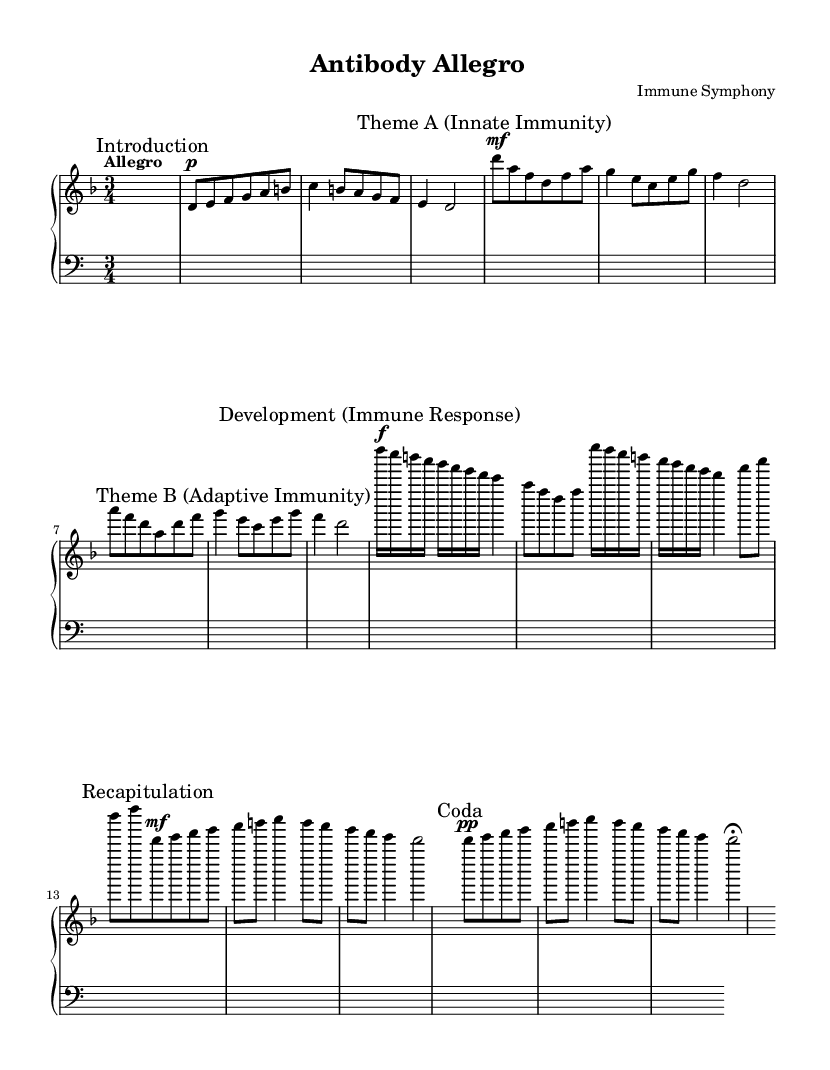What is the key signature of this music? The key signature is indicated at the beginning of the piece. It shows two flats, which corresponds to D minor.
Answer: D minor What is the time signature of this music? The time signature is shown in the staff and is written as a fraction, indicating three beats in each measure, which is signified as '3/4'.
Answer: 3/4 What is the tempo marking? The tempo marking is written right above the music staff and reads "Allegro," indicating a fast and lively speed of play.
Answer: Allegro How many themes are presented in this piece? Counting the marked sections in the sheet music, "Theme A" and "Theme B" indicate there are two distinct themes in the piece.
Answer: 2 What is the dynamic marking at the beginning of the Development section? The Development section starts with a dynamic marking of 'f', which directs the performer to play loudly at the beginning of this segment.
Answer: f Which section contains the Coda? The Coda section is designated with a marked heading, situated at the end of the piece, outlining the concluding remarks of the music.
Answer: Coda 